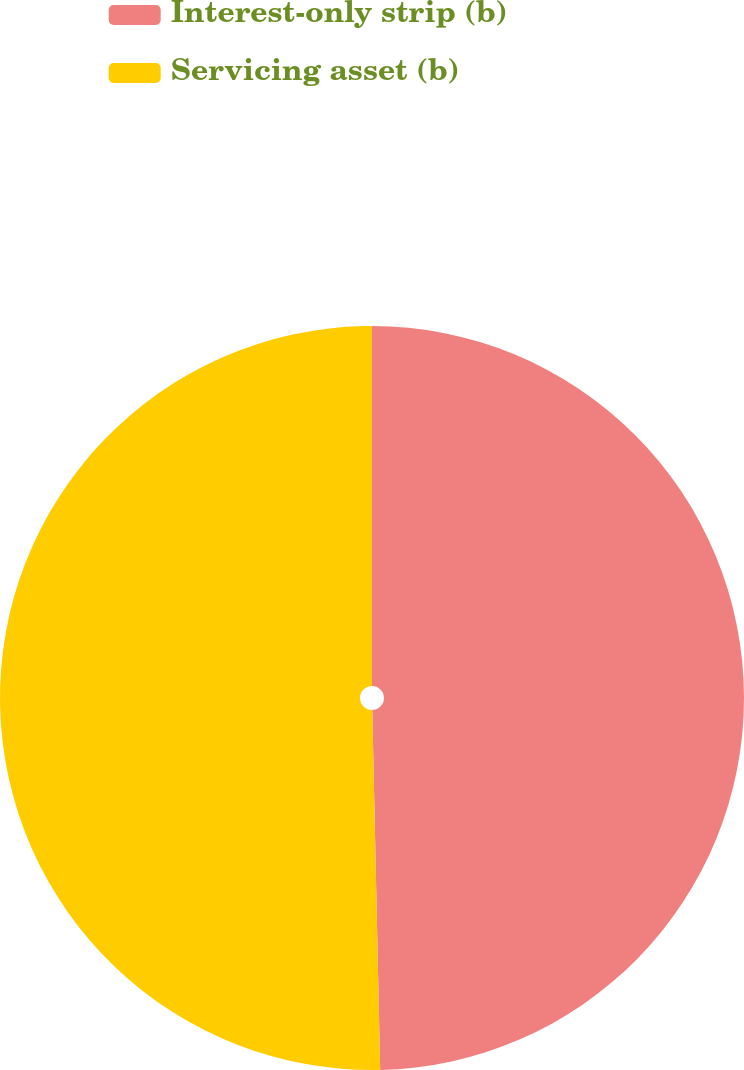<chart> <loc_0><loc_0><loc_500><loc_500><pie_chart><fcel>Interest-only strip (b)<fcel>Servicing asset (b)<nl><fcel>49.65%<fcel>50.35%<nl></chart> 